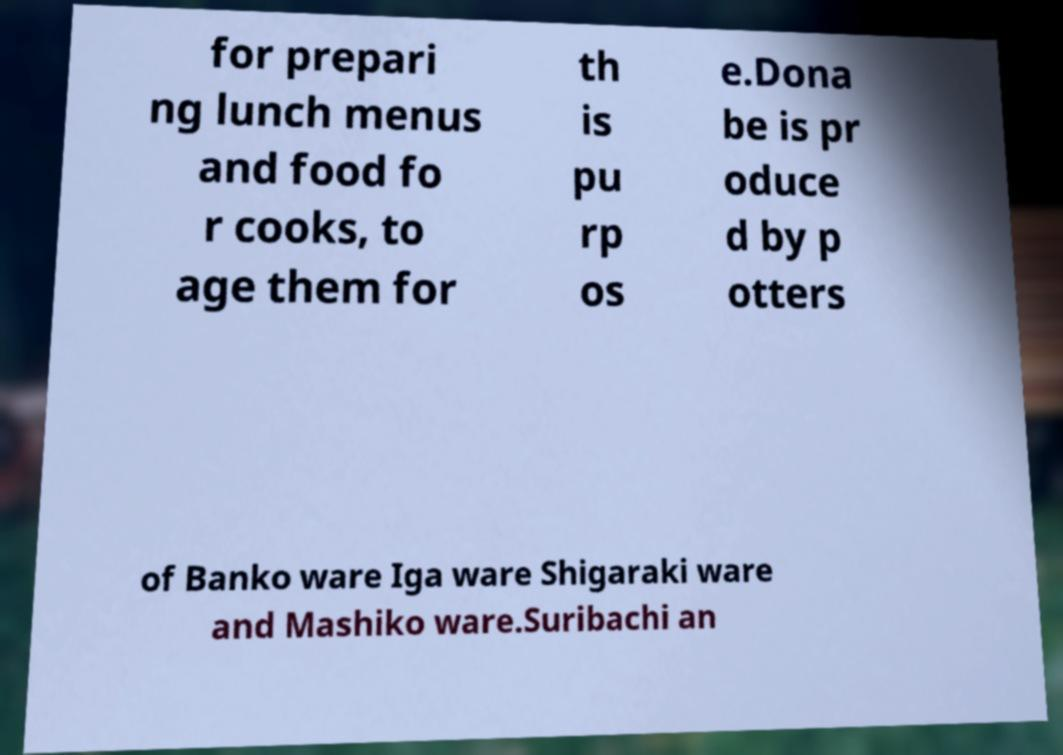I need the written content from this picture converted into text. Can you do that? for prepari ng lunch menus and food fo r cooks, to age them for th is pu rp os e.Dona be is pr oduce d by p otters of Banko ware Iga ware Shigaraki ware and Mashiko ware.Suribachi an 